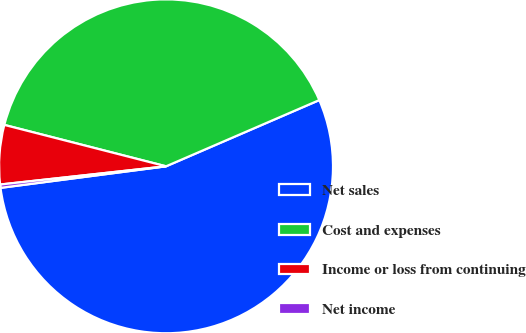Convert chart to OTSL. <chart><loc_0><loc_0><loc_500><loc_500><pie_chart><fcel>Net sales<fcel>Cost and expenses<fcel>Income or loss from continuing<fcel>Net income<nl><fcel>54.43%<fcel>39.52%<fcel>5.73%<fcel>0.32%<nl></chart> 